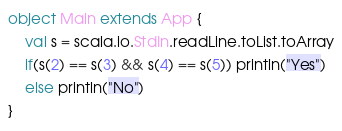Convert code to text. <code><loc_0><loc_0><loc_500><loc_500><_Scala_>object Main extends App {
	val s = scala.io.StdIn.readLine.toList.toArray
	if(s(2) == s(3) && s(4) == s(5)) println("Yes")
	else println("No")
}</code> 